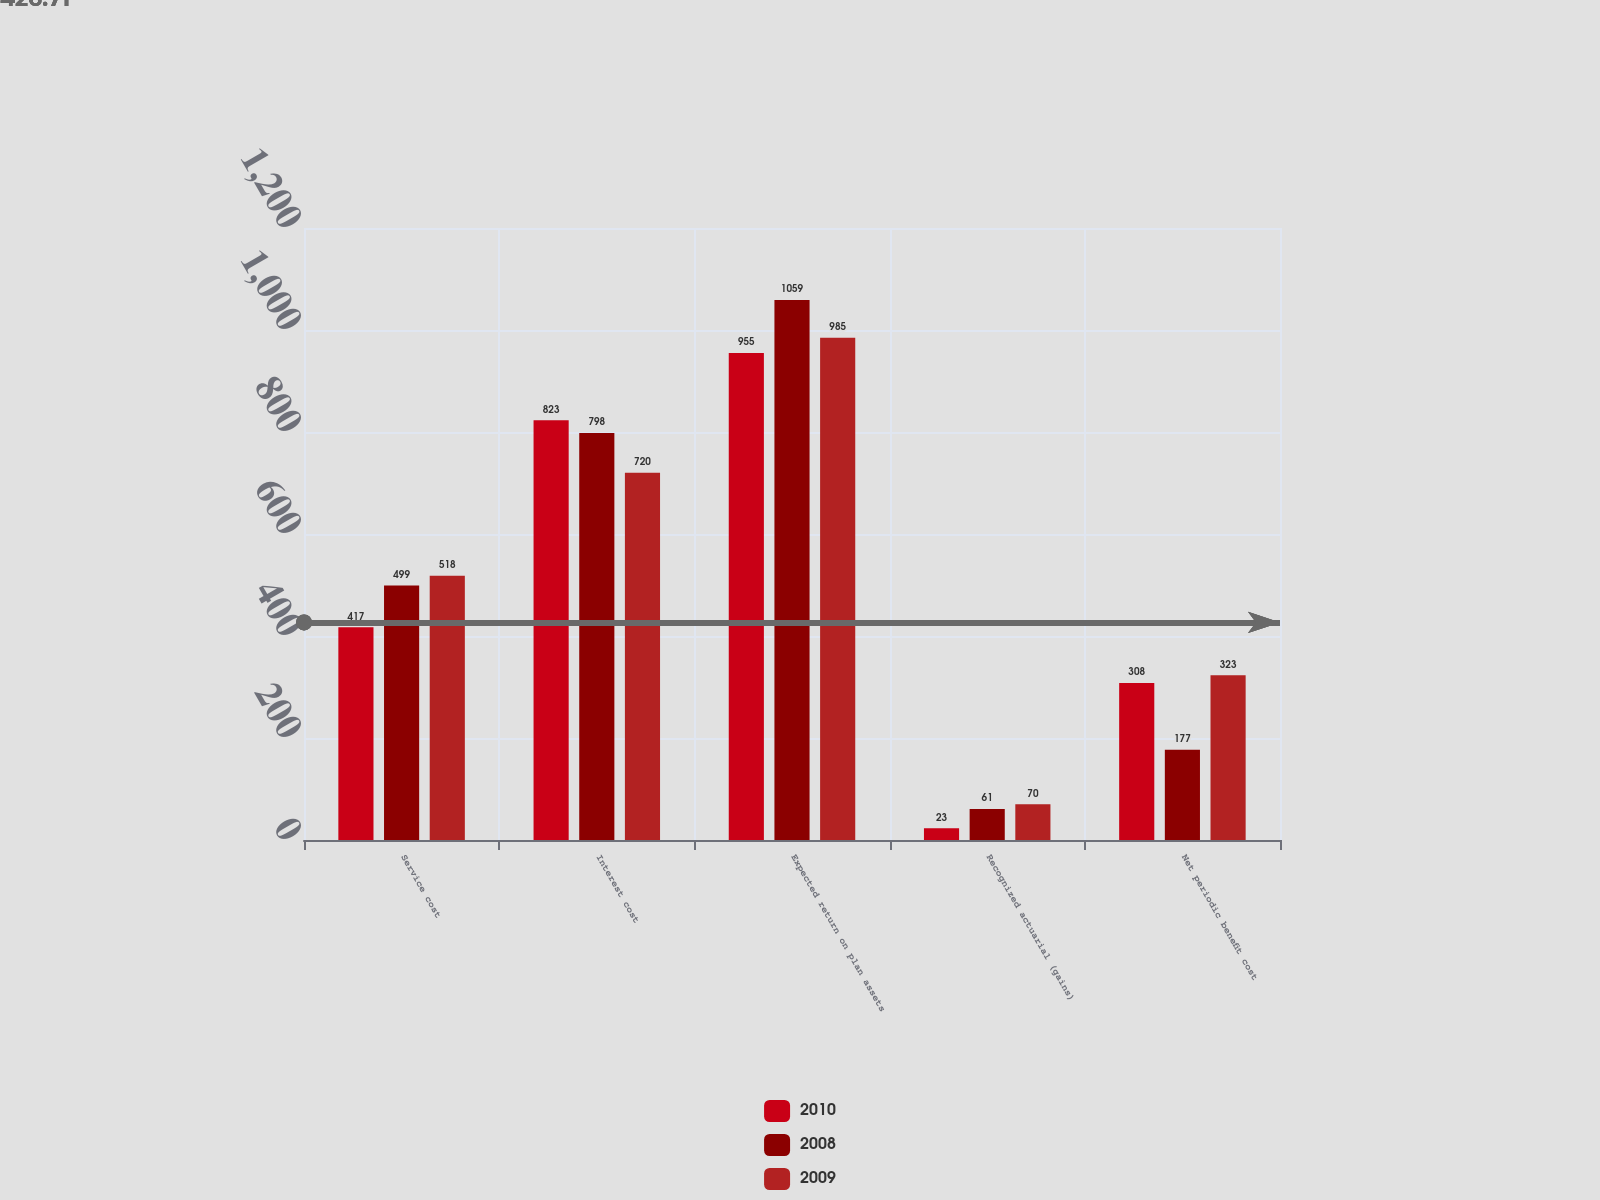<chart> <loc_0><loc_0><loc_500><loc_500><stacked_bar_chart><ecel><fcel>Service cost<fcel>Interest cost<fcel>Expected return on plan assets<fcel>Recognized actuarial (gains)<fcel>Net periodic benefit cost<nl><fcel>2010<fcel>417<fcel>823<fcel>955<fcel>23<fcel>308<nl><fcel>2008<fcel>499<fcel>798<fcel>1059<fcel>61<fcel>177<nl><fcel>2009<fcel>518<fcel>720<fcel>985<fcel>70<fcel>323<nl></chart> 